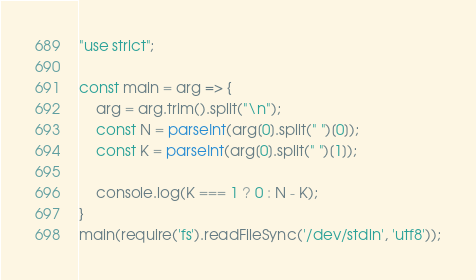Convert code to text. <code><loc_0><loc_0><loc_500><loc_500><_JavaScript_>"use strict";
    
const main = arg => {
    arg = arg.trim().split("\n");
    const N = parseInt(arg[0].split(" ")[0]);
    const K = parseInt(arg[0].split(" ")[1]);

    console.log(K === 1 ? 0 : N - K);
}
main(require('fs').readFileSync('/dev/stdin', 'utf8'));</code> 